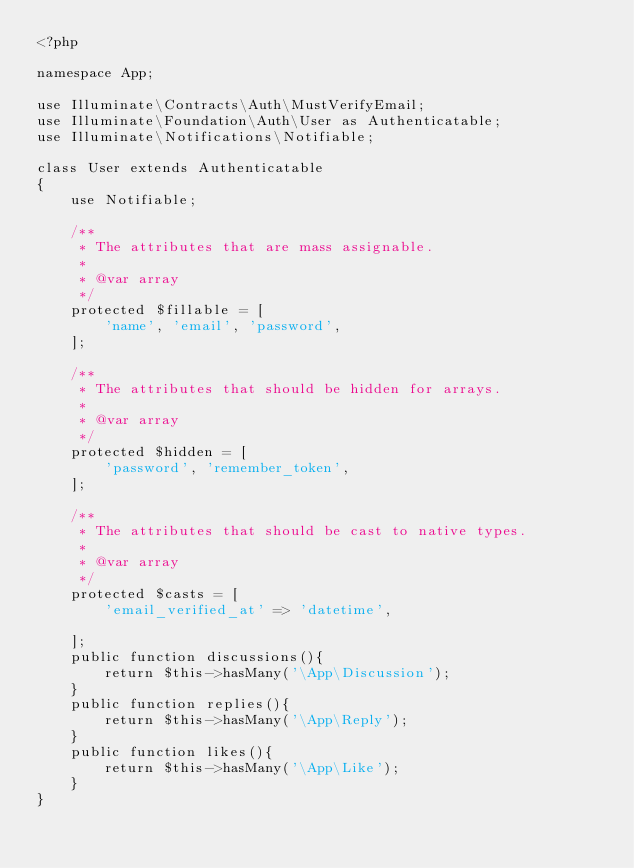<code> <loc_0><loc_0><loc_500><loc_500><_PHP_><?php

namespace App;

use Illuminate\Contracts\Auth\MustVerifyEmail;
use Illuminate\Foundation\Auth\User as Authenticatable;
use Illuminate\Notifications\Notifiable;

class User extends Authenticatable 
{
    use Notifiable;

    /**
     * The attributes that are mass assignable.
     *
     * @var array
     */
    protected $fillable = [
        'name', 'email', 'password',
    ];

    /**
     * The attributes that should be hidden for arrays.
     *
     * @var array
     */
    protected $hidden = [
        'password', 'remember_token',
    ];

    /**
     * The attributes that should be cast to native types.
     *
     * @var array
     */
    protected $casts = [
        'email_verified_at' => 'datetime',
        
    ];
    public function discussions(){
        return $this->hasMany('\App\Discussion');
    }
    public function replies(){
        return $this->hasMany('\App\Reply');
    }
    public function likes(){
        return $this->hasMany('\App\Like');
    }
}
</code> 